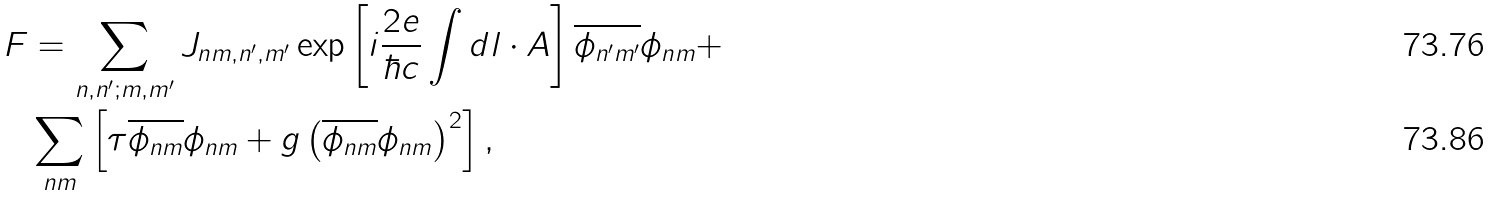Convert formula to latex. <formula><loc_0><loc_0><loc_500><loc_500>F & = \sum _ { n , n ^ { \prime } ; m , m ^ { \prime } } J _ { n m , n ^ { \prime } , m ^ { \prime } } \exp \left [ i \frac { 2 e } { \hbar { c } } \int d l \cdot A \right ] \overline { \phi _ { n ^ { \prime } m ^ { \prime } } } \phi _ { n m } + \\ & \sum _ { n m } \left [ \tau \overline { \phi _ { n m } } \phi _ { n m } + g \left ( \overline { \phi _ { n m } } \phi _ { n m } \right ) ^ { 2 } \right ] ,</formula> 